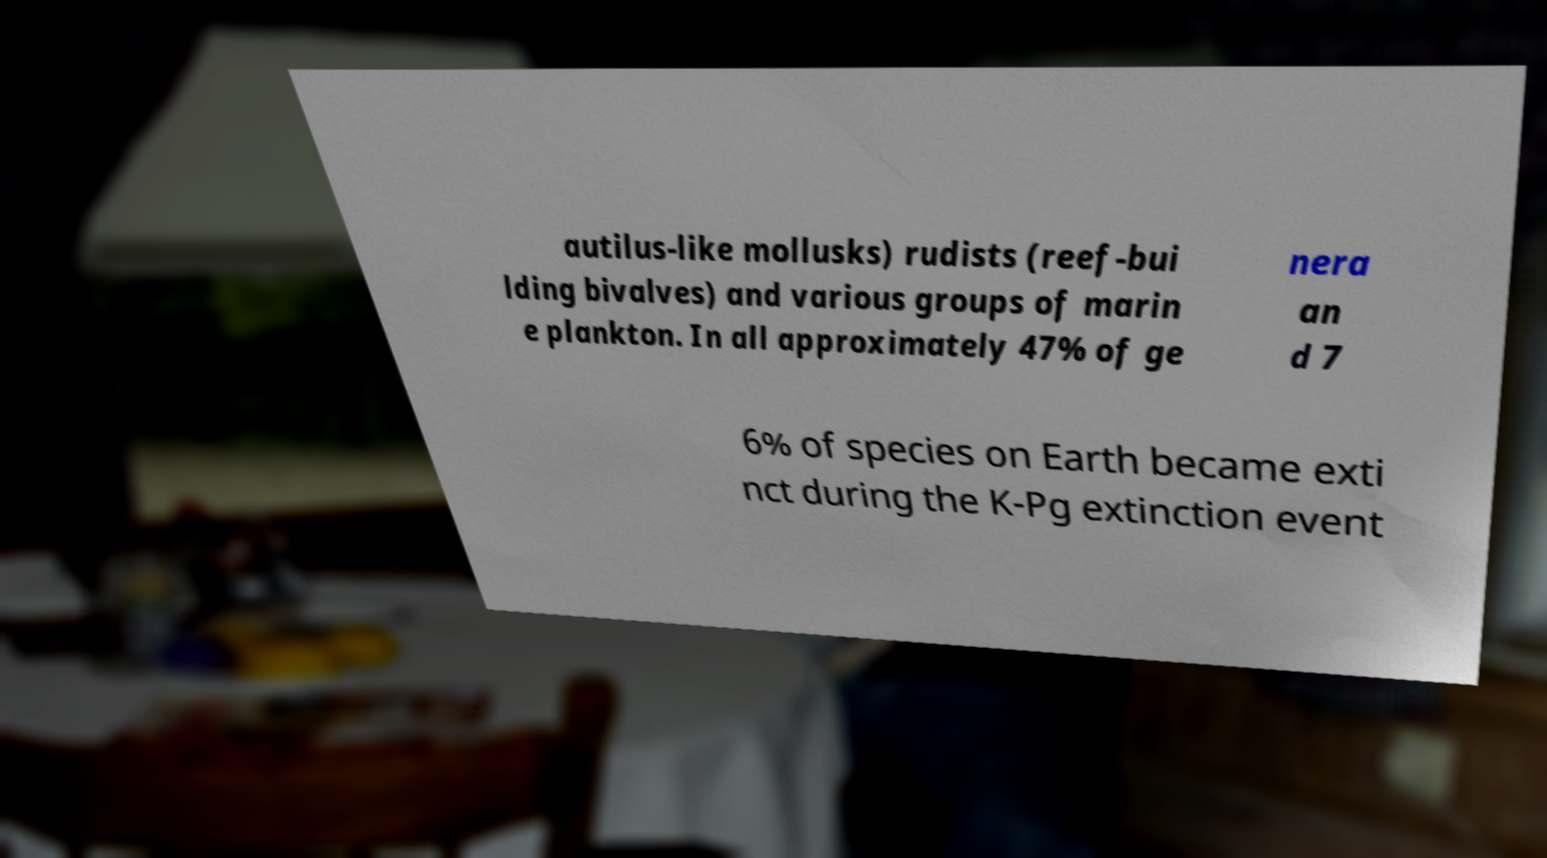Please identify and transcribe the text found in this image. autilus-like mollusks) rudists (reef-bui lding bivalves) and various groups of marin e plankton. In all approximately 47% of ge nera an d 7 6% of species on Earth became exti nct during the K-Pg extinction event 